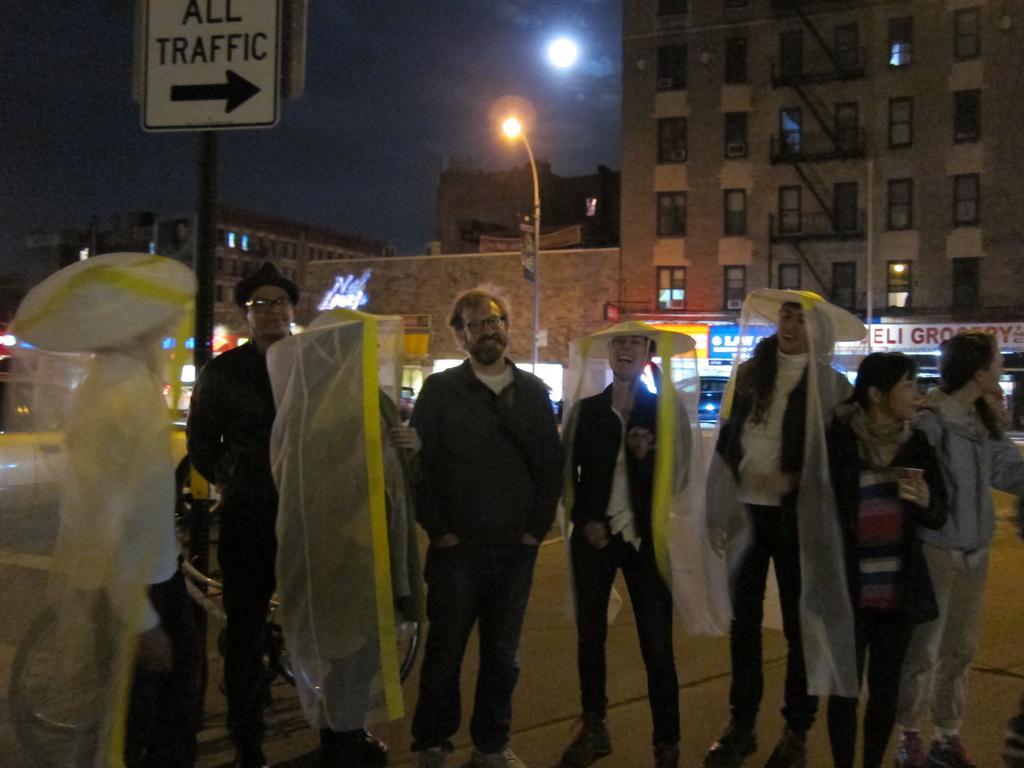How would you summarize this image in a sentence or two? In this picture there are group of people standing where few among them are wearing an object which is in yellow and white color and there are buildings in the background. 